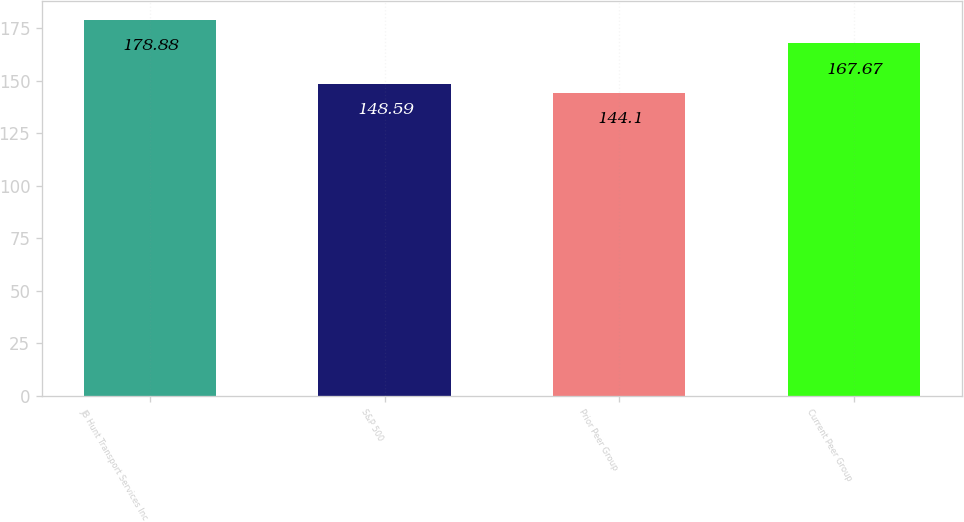Convert chart. <chart><loc_0><loc_0><loc_500><loc_500><bar_chart><fcel>JB Hunt Transport Services Inc<fcel>S&P 500<fcel>Prior Peer Group<fcel>Current Peer Group<nl><fcel>178.88<fcel>148.59<fcel>144.1<fcel>167.67<nl></chart> 